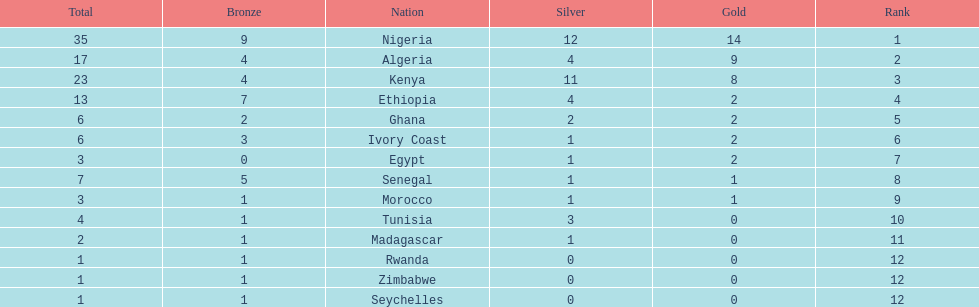The team possessing the greatest amount of gold medals is? Nigeria. 